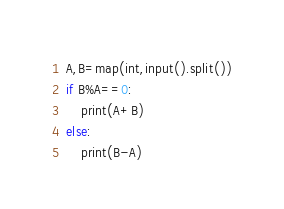<code> <loc_0><loc_0><loc_500><loc_500><_Python_>A,B=map(int,input().split())
if B%A==0:
    print(A+B)
else:
    print(B-A)</code> 